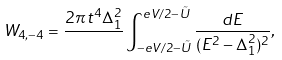Convert formula to latex. <formula><loc_0><loc_0><loc_500><loc_500>W _ { 4 , - 4 } = \frac { 2 \pi \, t ^ { 4 } \Delta _ { 1 } ^ { 2 } } { } \int _ { - e V / 2 - \tilde { U } } ^ { e V / 2 - \tilde { U } } \frac { d E } { ( E ^ { 2 } - \Delta _ { 1 } ^ { 2 } ) ^ { 2 } } ,</formula> 